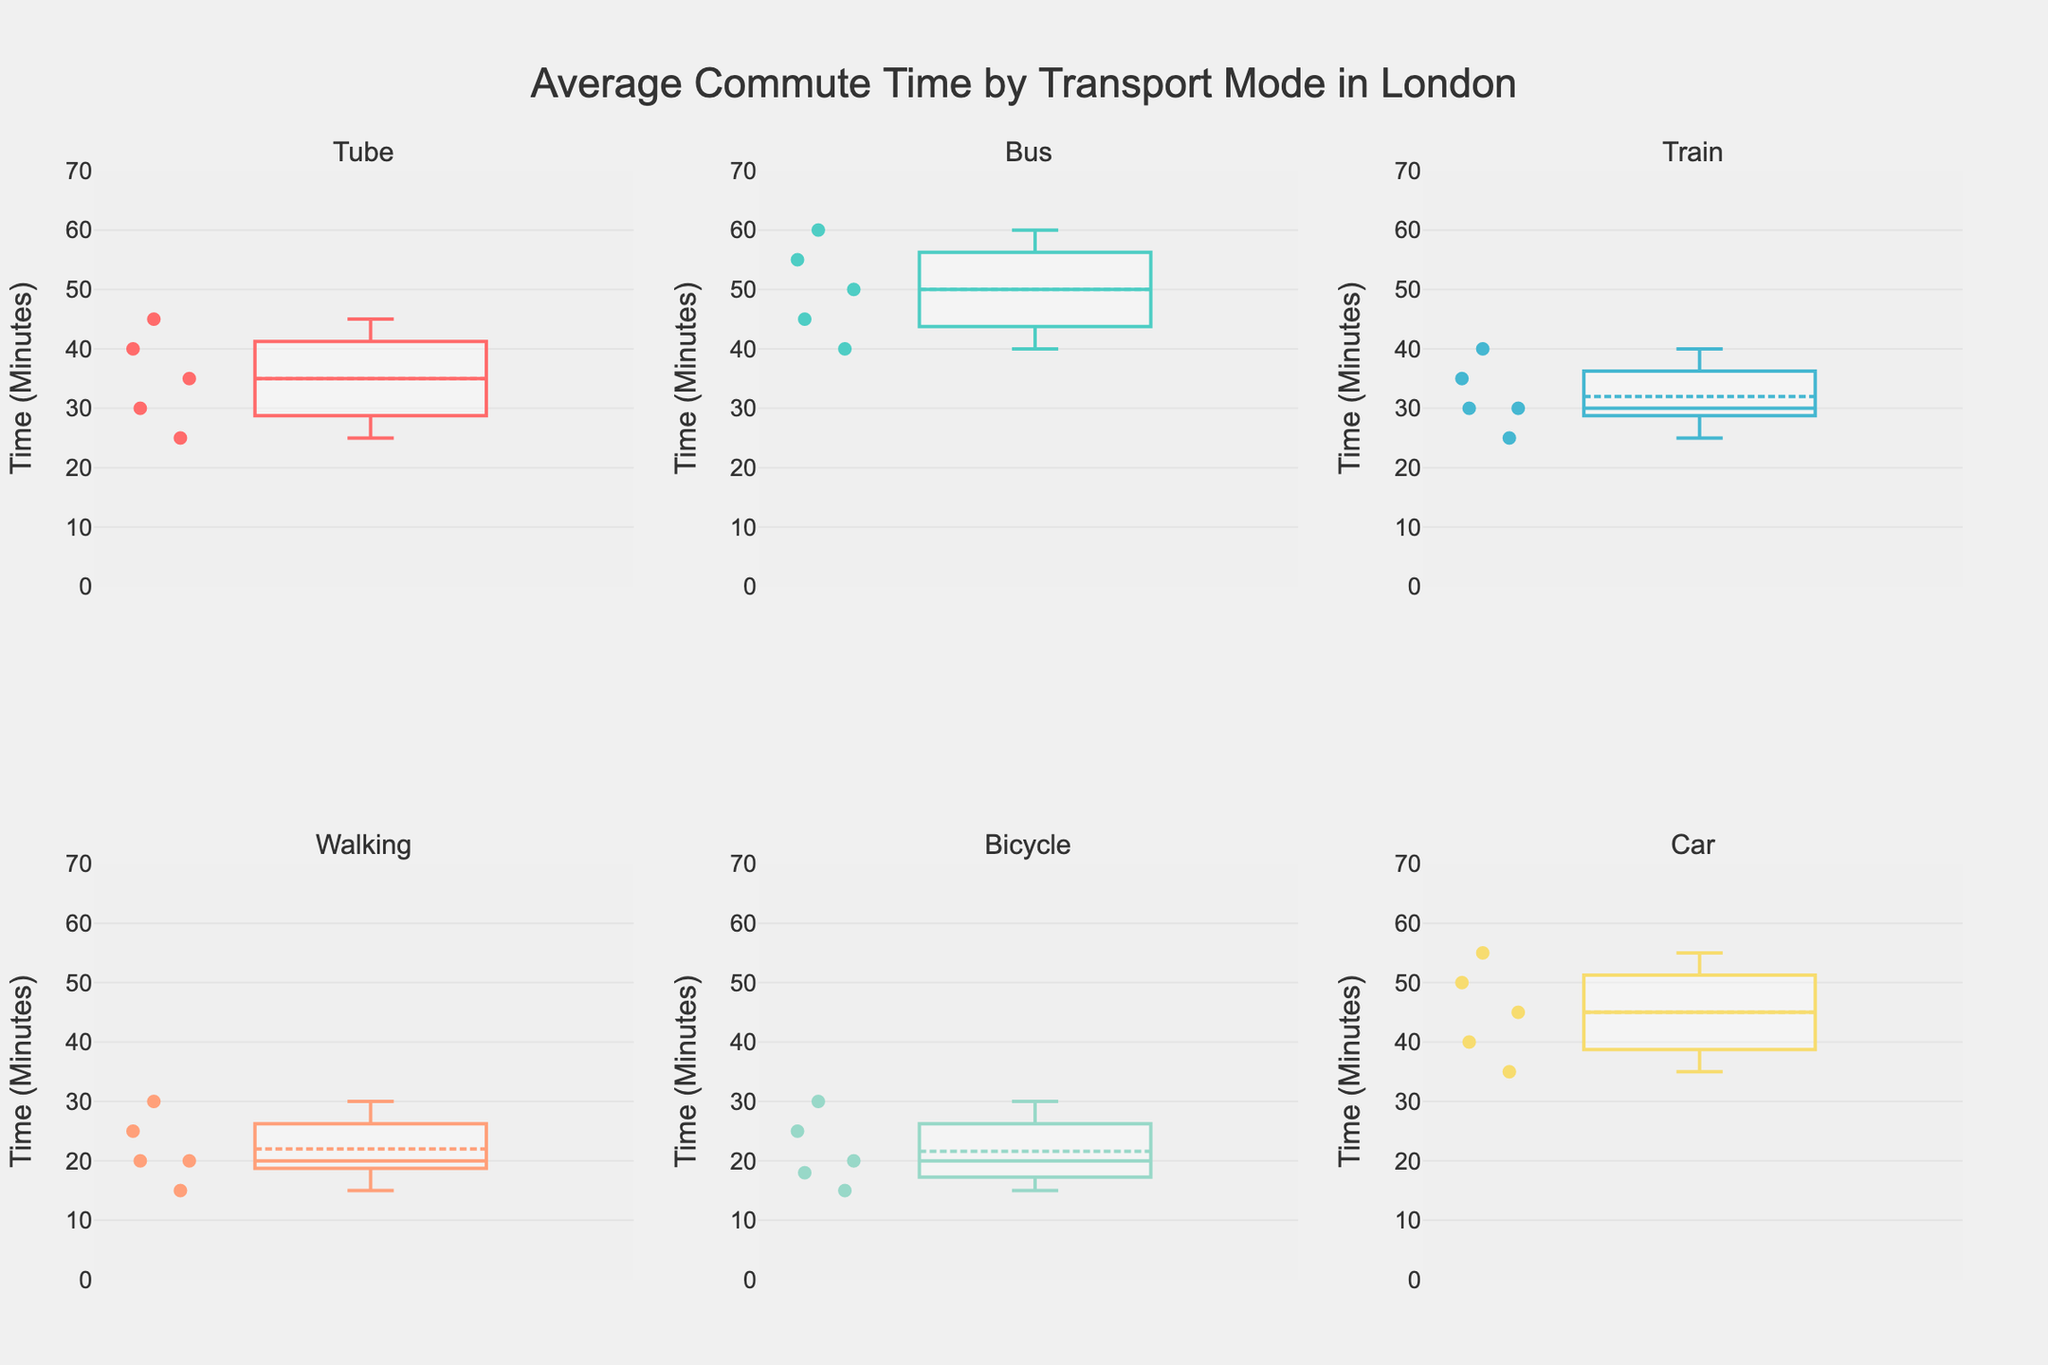Which transport mode has the lowest median commute time? By examining the boxes in each subplot, the median is represented by the line within the box. The transport mode with the lowest median is Walking.
Answer: Walking How many transport modes are displayed in the figure? The subplot titles indicate the number of transport modes, and each mode has its own subplot. There are 6 subplots.
Answer: 6 Which transport mode has the highest maximum commute time? The maximum time is depicted by the top whisker in each box plot. The subplot for Bus shows the highest maximum value.
Answer: Bus Is the average commute time for the Tube higher than for Walking? Examine the boxplot summaries for Tube and Walking; the Tube shows a higher average in its box plot compared to Walking.
Answer: Yes Which transport mode has the smallest interquartile range (IQR) and what is it? The IQR is represented by the height of the box (distance between Q1 and Q3). The smallest IQR appears in the Walking subplot. To find the exact values, refer to the respective quartiles.
Answer: Walking How does the median commute time for Bicycle compare to that of Car? Compare the median lines in the Bicycle and Car subplots. The median commute time for Bicycle is lower than for Car.
Answer: Lower What is the most significant outlier in the subplots? Outliers are shown as individual points beyond the whiskers in each box plot. The most significant outlier is in the Car subplot with a marked point upwards of 55 minutes.
Answer: Car What does the title of the figure suggest about the data represented? The title "Average Commute Time by Transport Mode in London" indicates that the box plots display commute times for different transport modes used by Londoners.
Answer: Average Commute Time by Transport Mode in London 